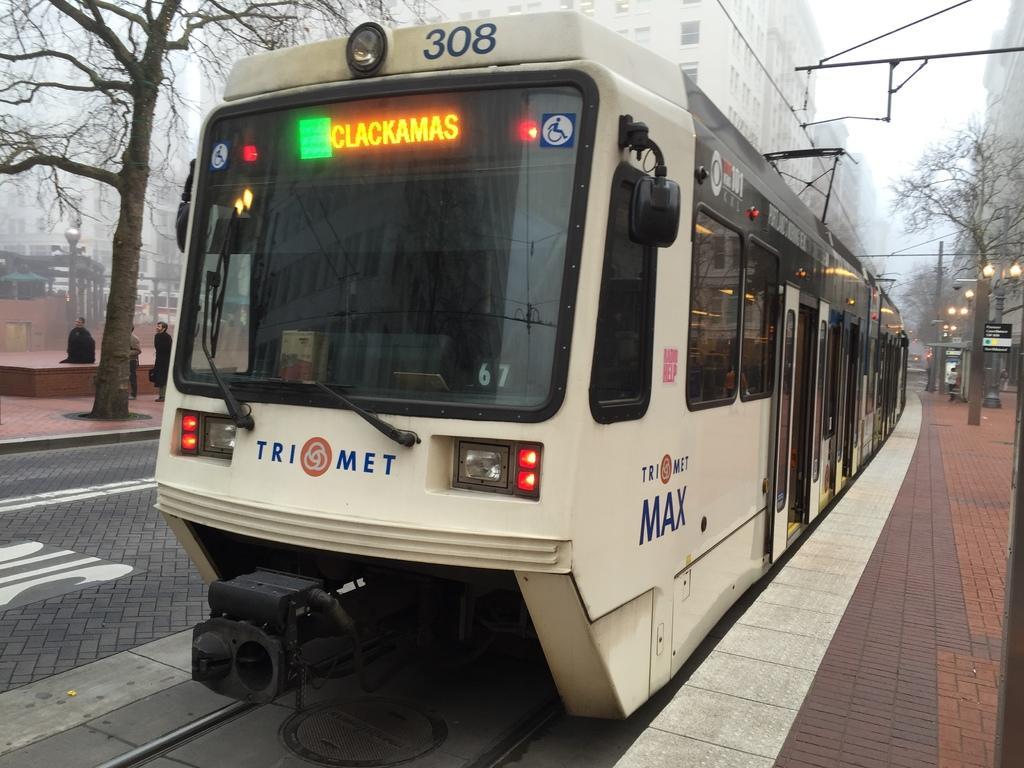Can you describe this image briefly? In the image we can see there is a train standing on the track and there are people standing on the footpath. There are trees and there are buildings. There are street lights on the footpath. 